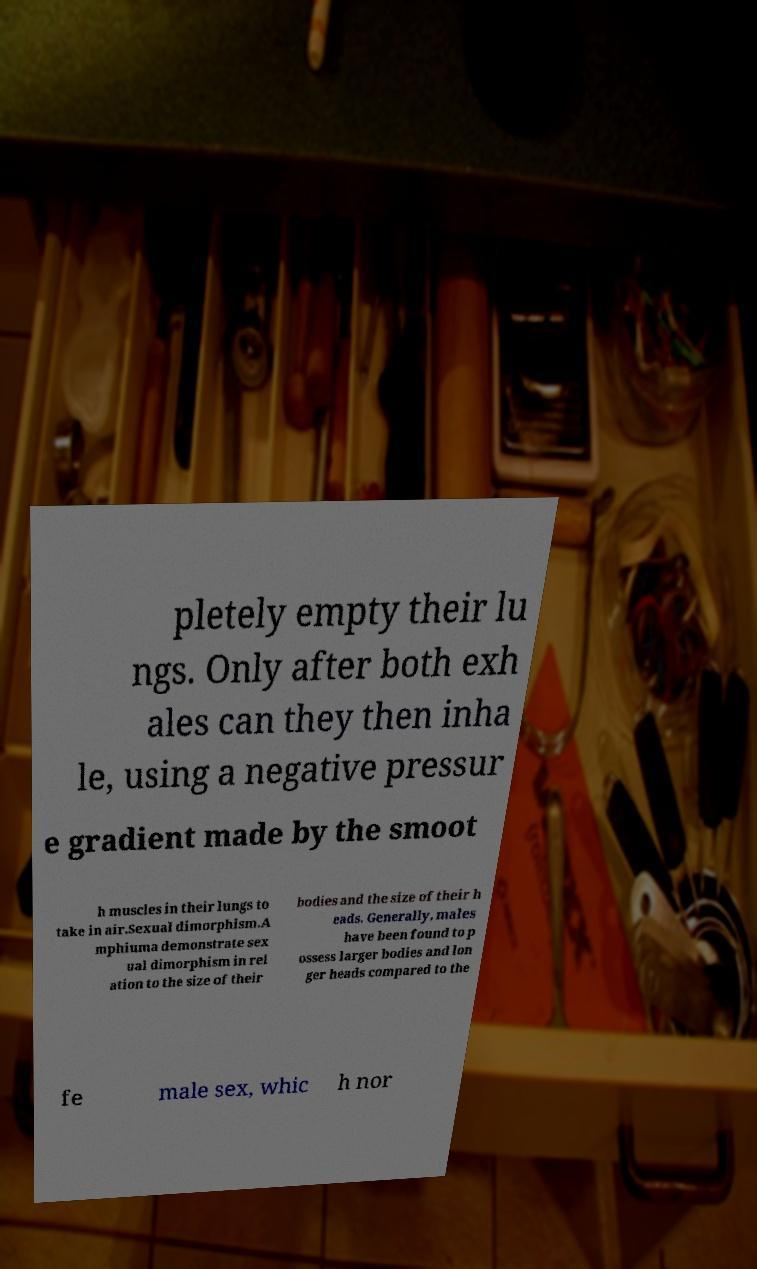For documentation purposes, I need the text within this image transcribed. Could you provide that? pletely empty their lu ngs. Only after both exh ales can they then inha le, using a negative pressur e gradient made by the smoot h muscles in their lungs to take in air.Sexual dimorphism.A mphiuma demonstrate sex ual dimorphism in rel ation to the size of their bodies and the size of their h eads. Generally, males have been found to p ossess larger bodies and lon ger heads compared to the fe male sex, whic h nor 